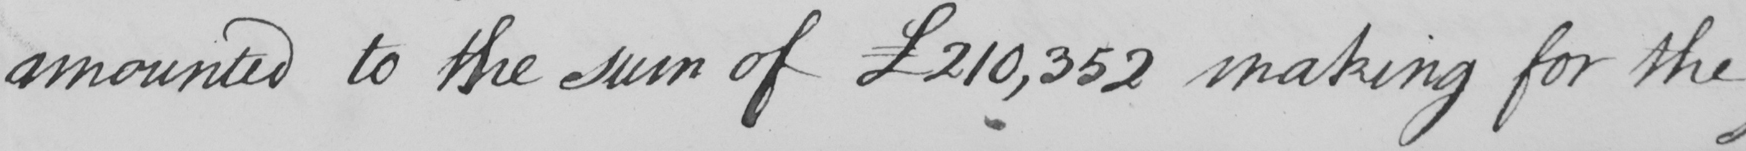Please provide the text content of this handwritten line. amounted to the sum of  £210,352 making for the 